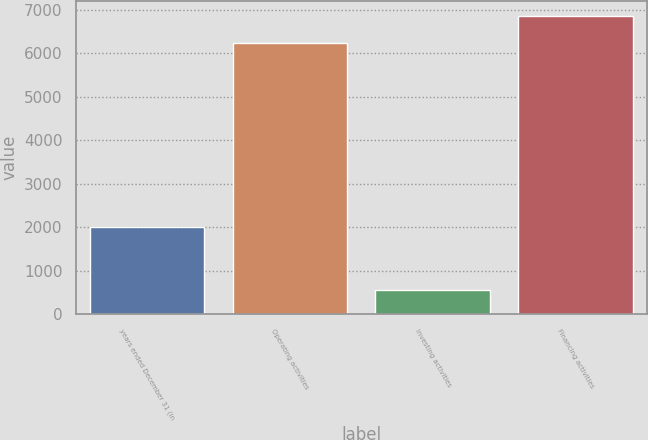Convert chart to OTSL. <chart><loc_0><loc_0><loc_500><loc_500><bar_chart><fcel>years ended December 31 (in<fcel>Operating activities<fcel>Investing activities<fcel>Financing activities<nl><fcel>2011<fcel>6247<fcel>553<fcel>6870<nl></chart> 